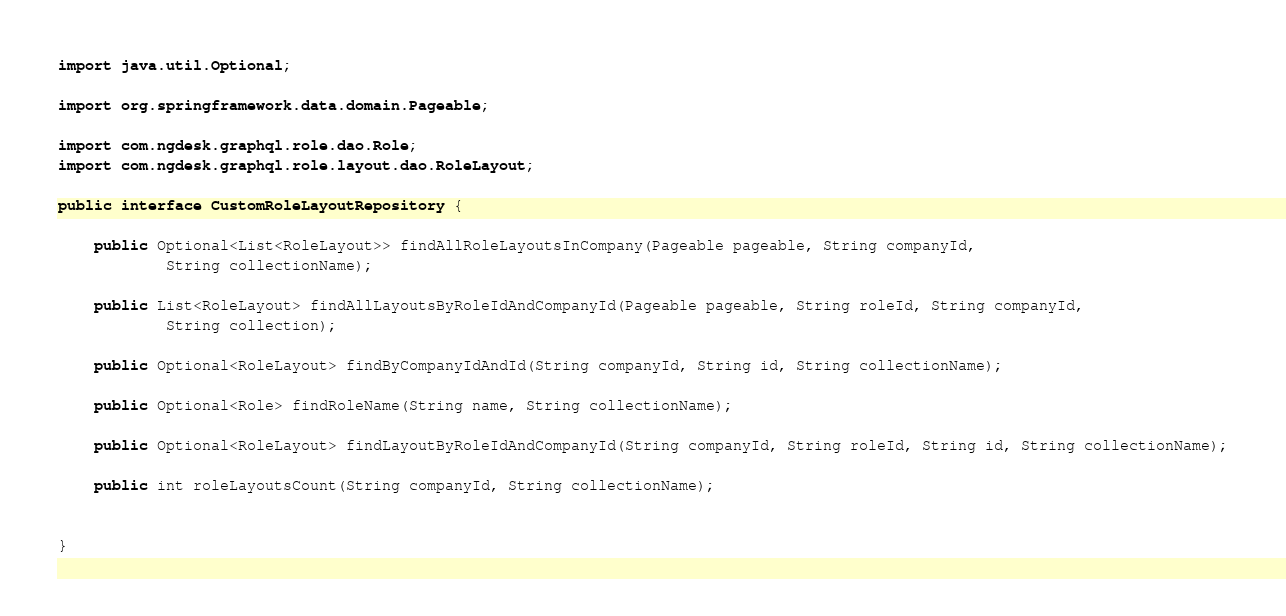<code> <loc_0><loc_0><loc_500><loc_500><_Java_>import java.util.Optional;

import org.springframework.data.domain.Pageable;

import com.ngdesk.graphql.role.dao.Role;
import com.ngdesk.graphql.role.layout.dao.RoleLayout;

public interface CustomRoleLayoutRepository {

	public Optional<List<RoleLayout>> findAllRoleLayoutsInCompany(Pageable pageable, String companyId,
			String collectionName);

	public List<RoleLayout> findAllLayoutsByRoleIdAndCompanyId(Pageable pageable, String roleId, String companyId,
			String collection);

	public Optional<RoleLayout> findByCompanyIdAndId(String companyId, String id, String collectionName);

	public Optional<Role> findRoleName(String name, String collectionName);

	public Optional<RoleLayout> findLayoutByRoleIdAndCompanyId(String companyId, String roleId, String id, String collectionName);
	
	public int roleLayoutsCount(String companyId, String collectionName);


}
</code> 